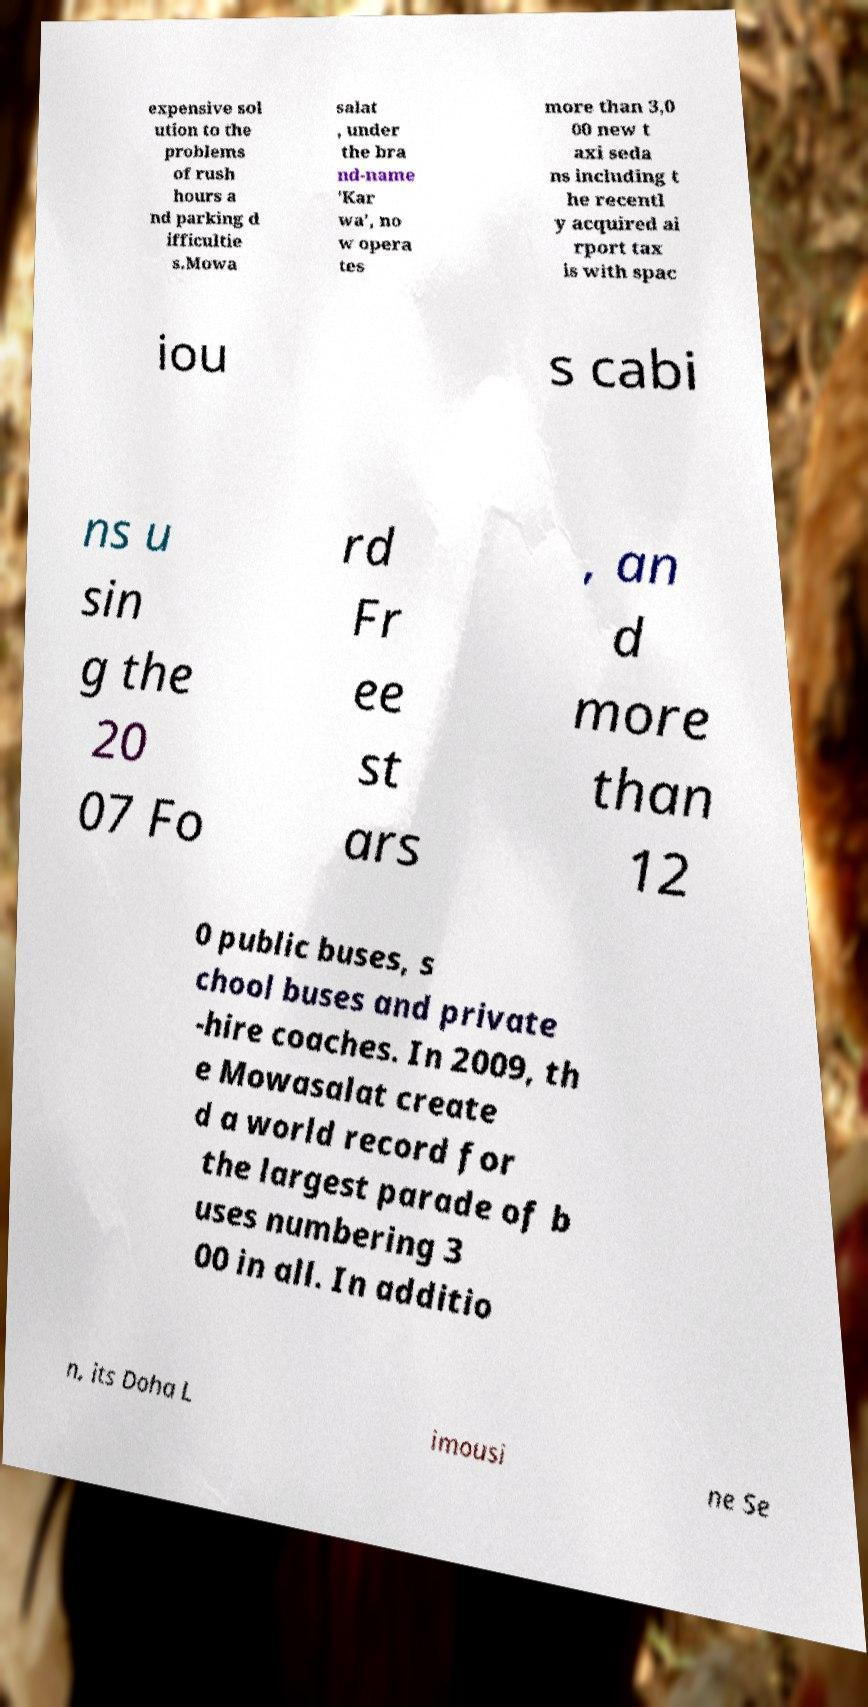Please read and relay the text visible in this image. What does it say? expensive sol ution to the problems of rush hours a nd parking d ifficultie s.Mowa salat , under the bra nd-name 'Kar wa', no w opera tes more than 3,0 00 new t axi seda ns including t he recentl y acquired ai rport tax is with spac iou s cabi ns u sin g the 20 07 Fo rd Fr ee st ars , an d more than 12 0 public buses, s chool buses and private -hire coaches. In 2009, th e Mowasalat create d a world record for the largest parade of b uses numbering 3 00 in all. In additio n, its Doha L imousi ne Se 